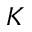<formula> <loc_0><loc_0><loc_500><loc_500>K</formula> 